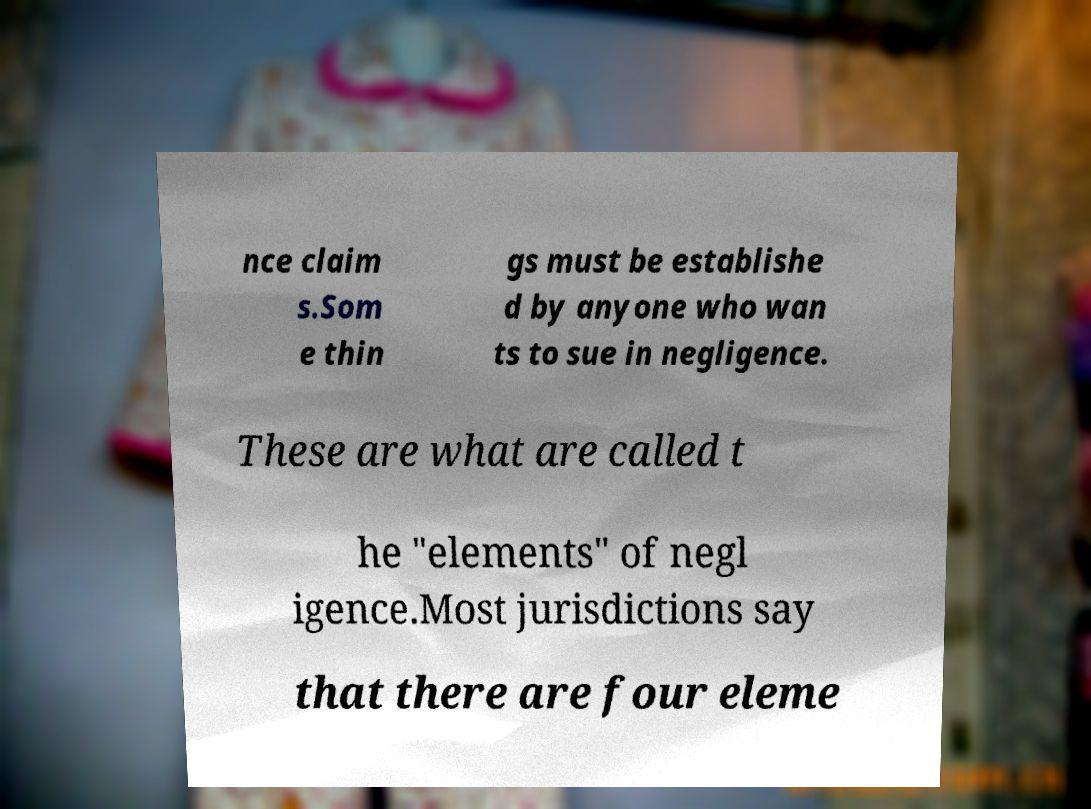There's text embedded in this image that I need extracted. Can you transcribe it verbatim? nce claim s.Som e thin gs must be establishe d by anyone who wan ts to sue in negligence. These are what are called t he "elements" of negl igence.Most jurisdictions say that there are four eleme 